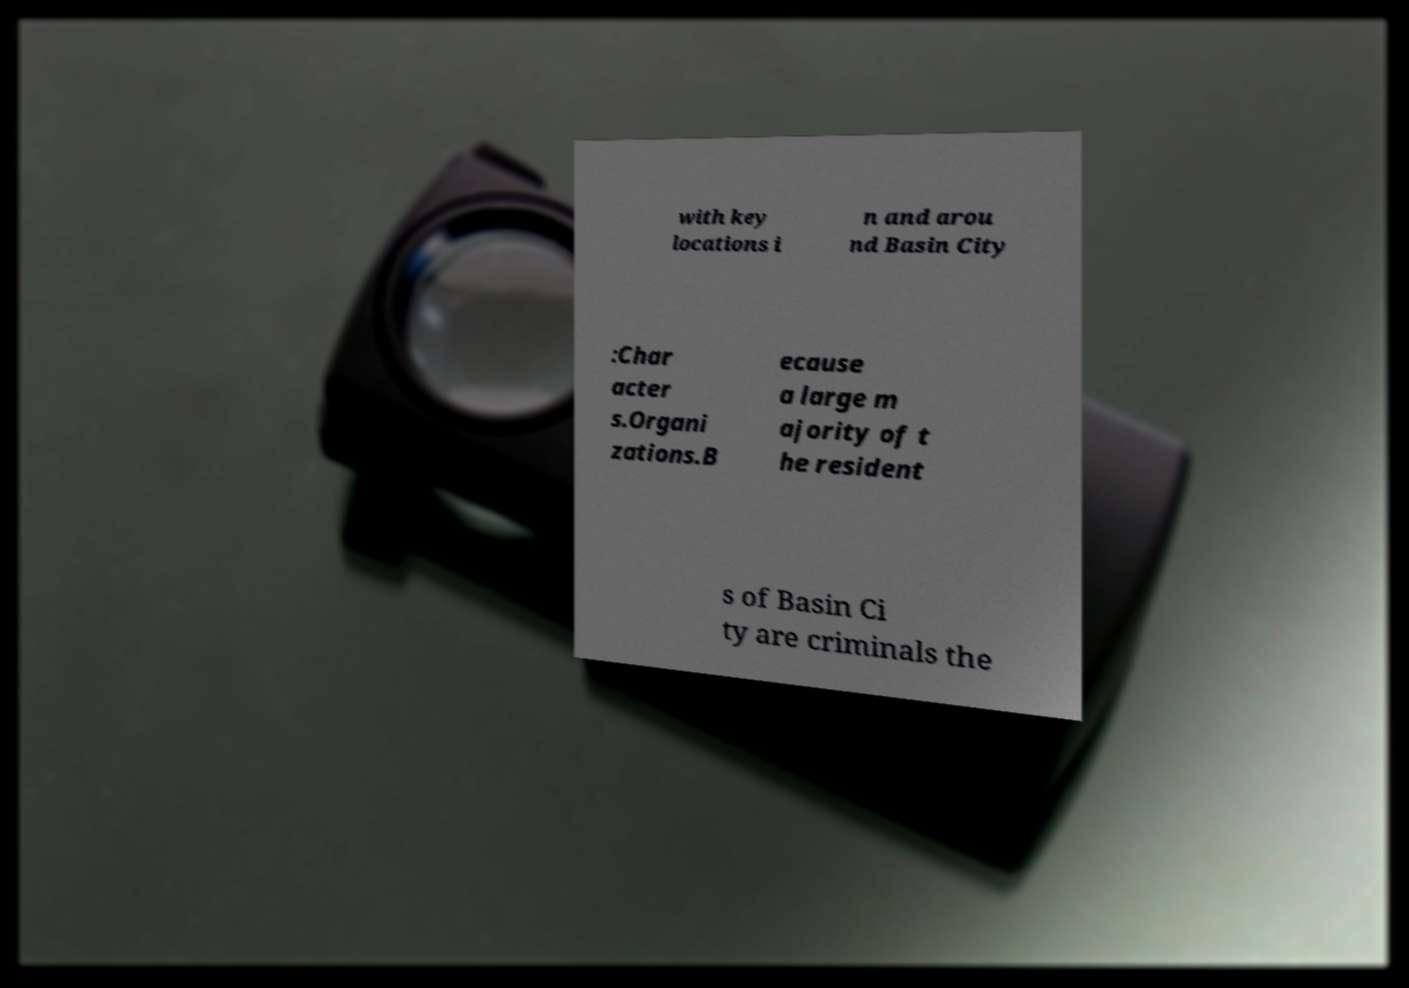What messages or text are displayed in this image? I need them in a readable, typed format. with key locations i n and arou nd Basin City :Char acter s.Organi zations.B ecause a large m ajority of t he resident s of Basin Ci ty are criminals the 